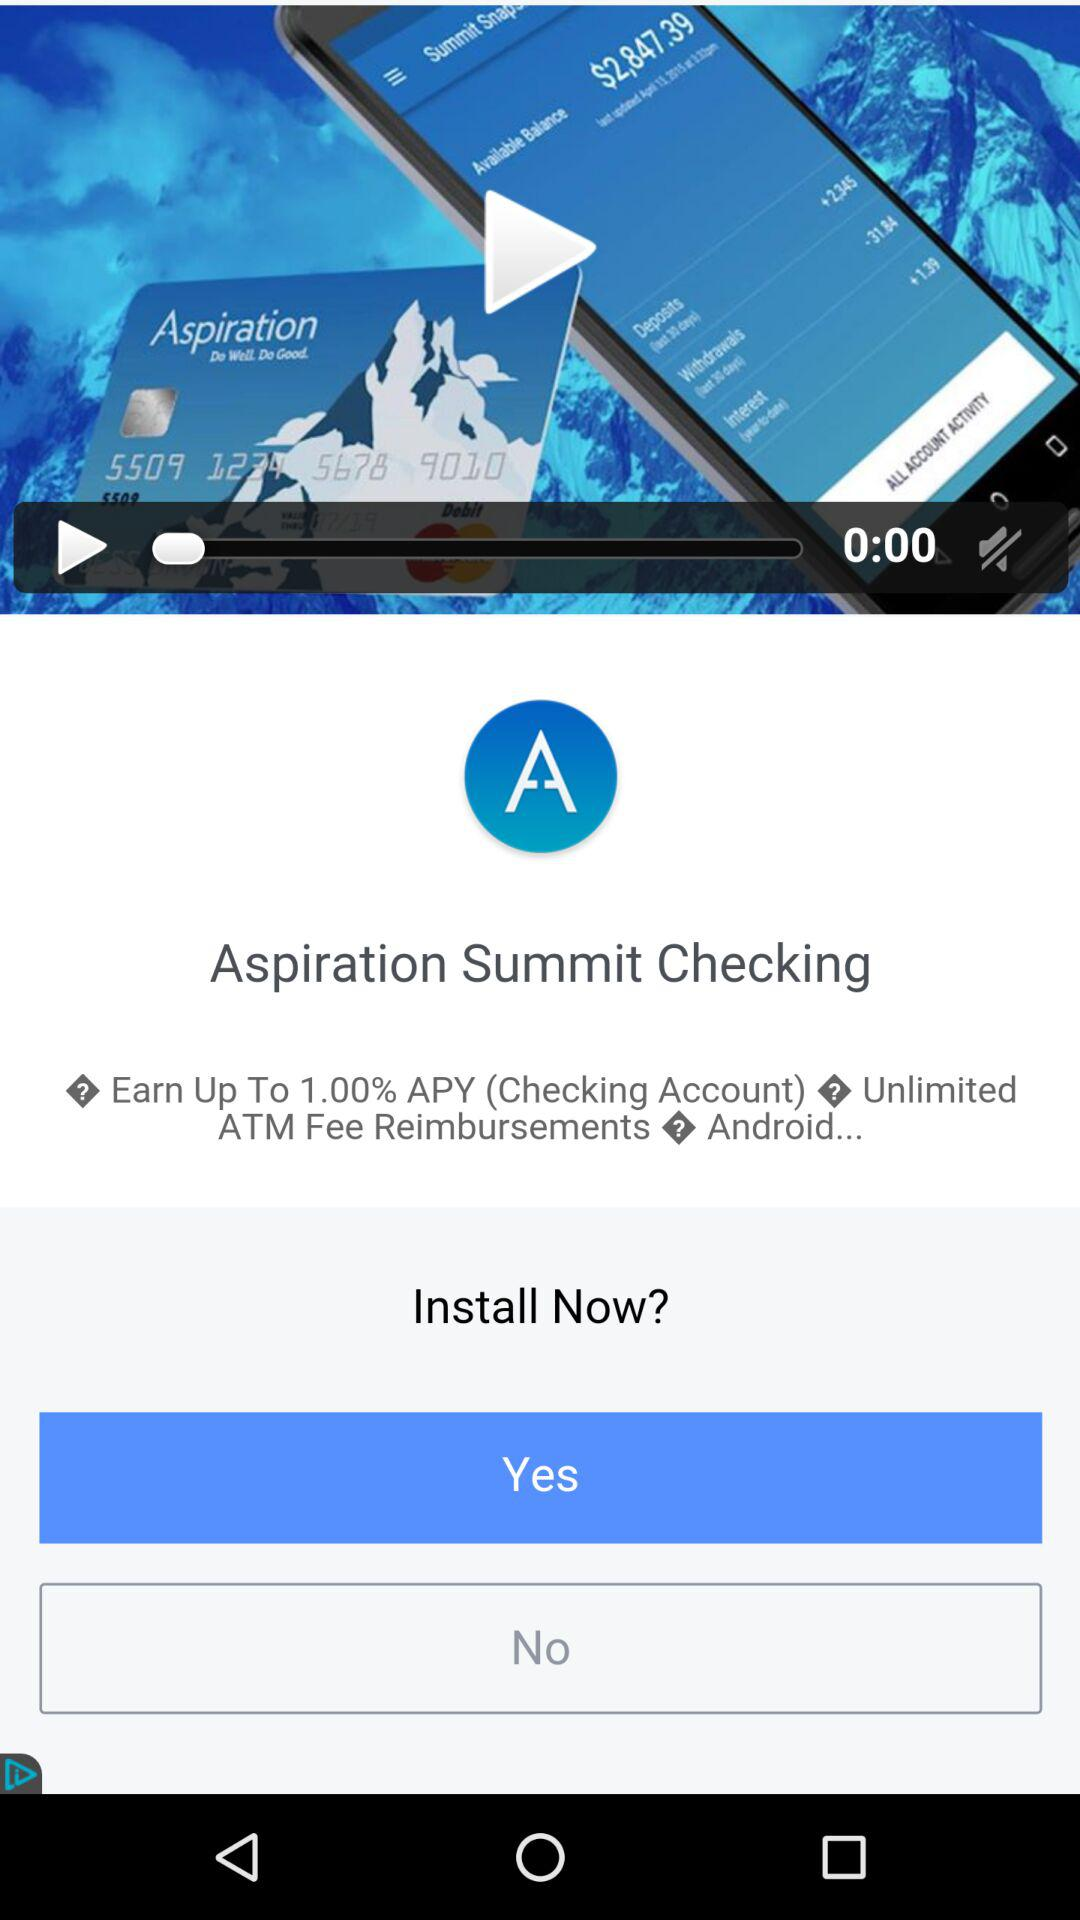How many question marks are there in the body of the ad?
Answer the question using a single word or phrase. 3 